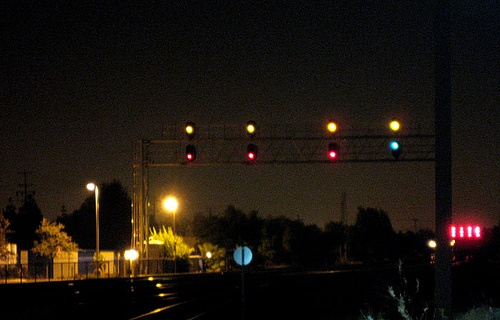Describe the objects in this image and their specific colors. I can see traffic light in black, maroon, white, and gold tones and traffic light in black, maroon, white, and yellow tones in this image. 